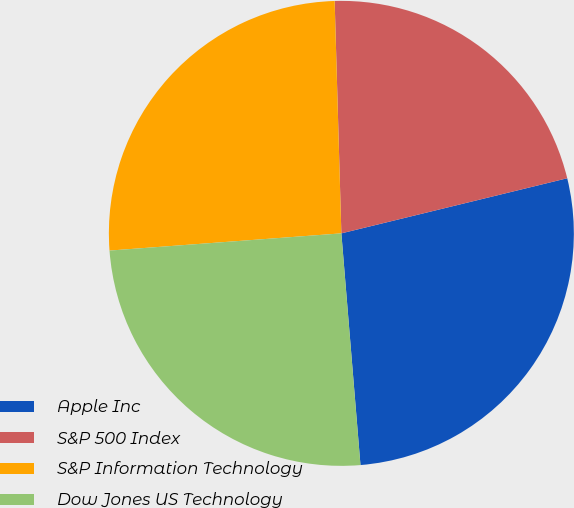Convert chart to OTSL. <chart><loc_0><loc_0><loc_500><loc_500><pie_chart><fcel>Apple Inc<fcel>S&P 500 Index<fcel>S&P Information Technology<fcel>Dow Jones US Technology<nl><fcel>27.5%<fcel>21.65%<fcel>25.72%<fcel>25.13%<nl></chart> 